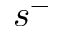Convert formula to latex. <formula><loc_0><loc_0><loc_500><loc_500>s ^ { - }</formula> 